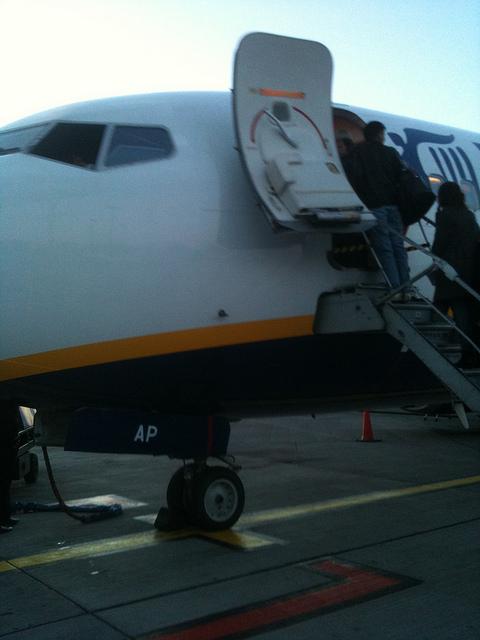Who is inside the plane?
Concise answer only. People. What kind of plane is this?
Give a very brief answer. Passenger. What two letters are on the bottom near the tires?
Keep it brief. Ap. Is the plane new?
Write a very short answer. No. Is the plane being loaded?
Concise answer only. Yes. Is the door of the plane open?
Write a very short answer. Yes. 